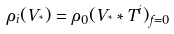Convert formula to latex. <formula><loc_0><loc_0><loc_500><loc_500>\rho _ { i } ( V _ { ^ { * } } ) = \rho _ { 0 } { ( V _ { ^ { * } } * T ^ { i } ) _ { f = 0 } }</formula> 